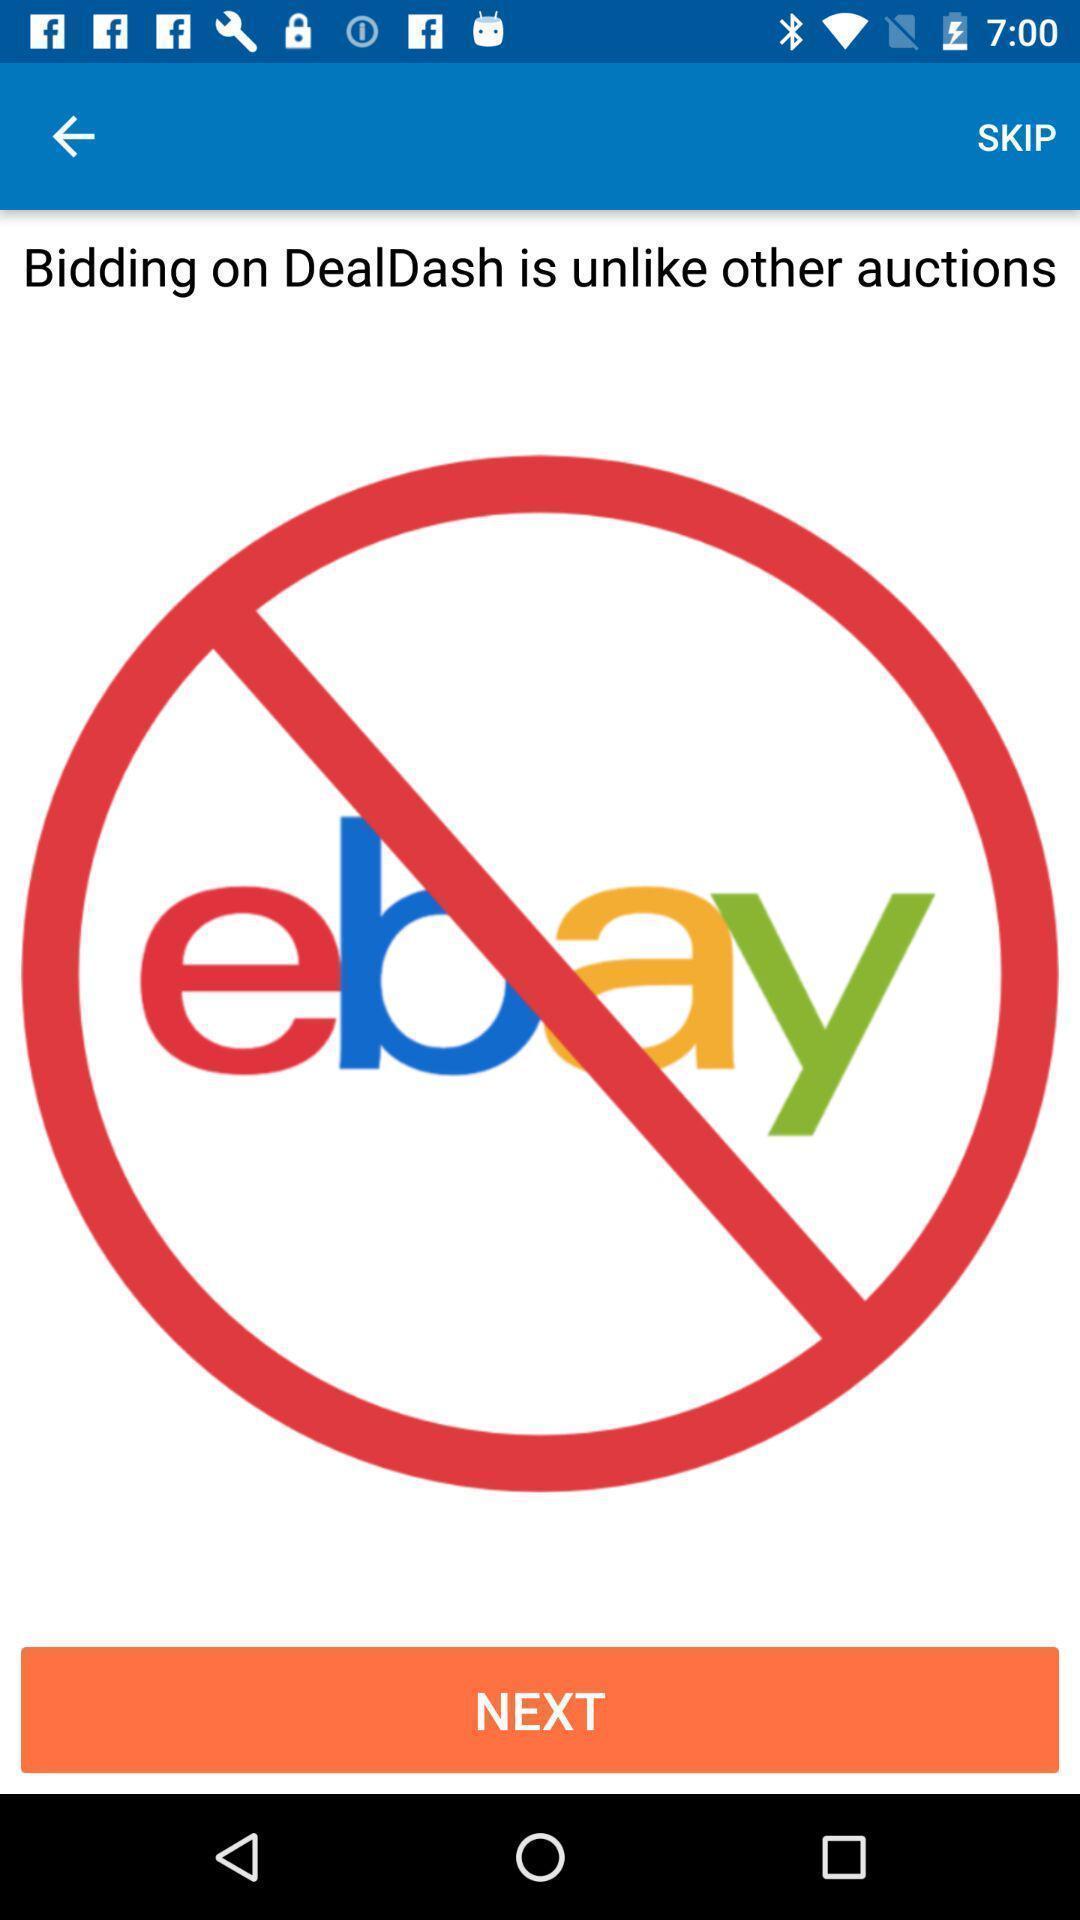Describe this image in words. Welcome page. 